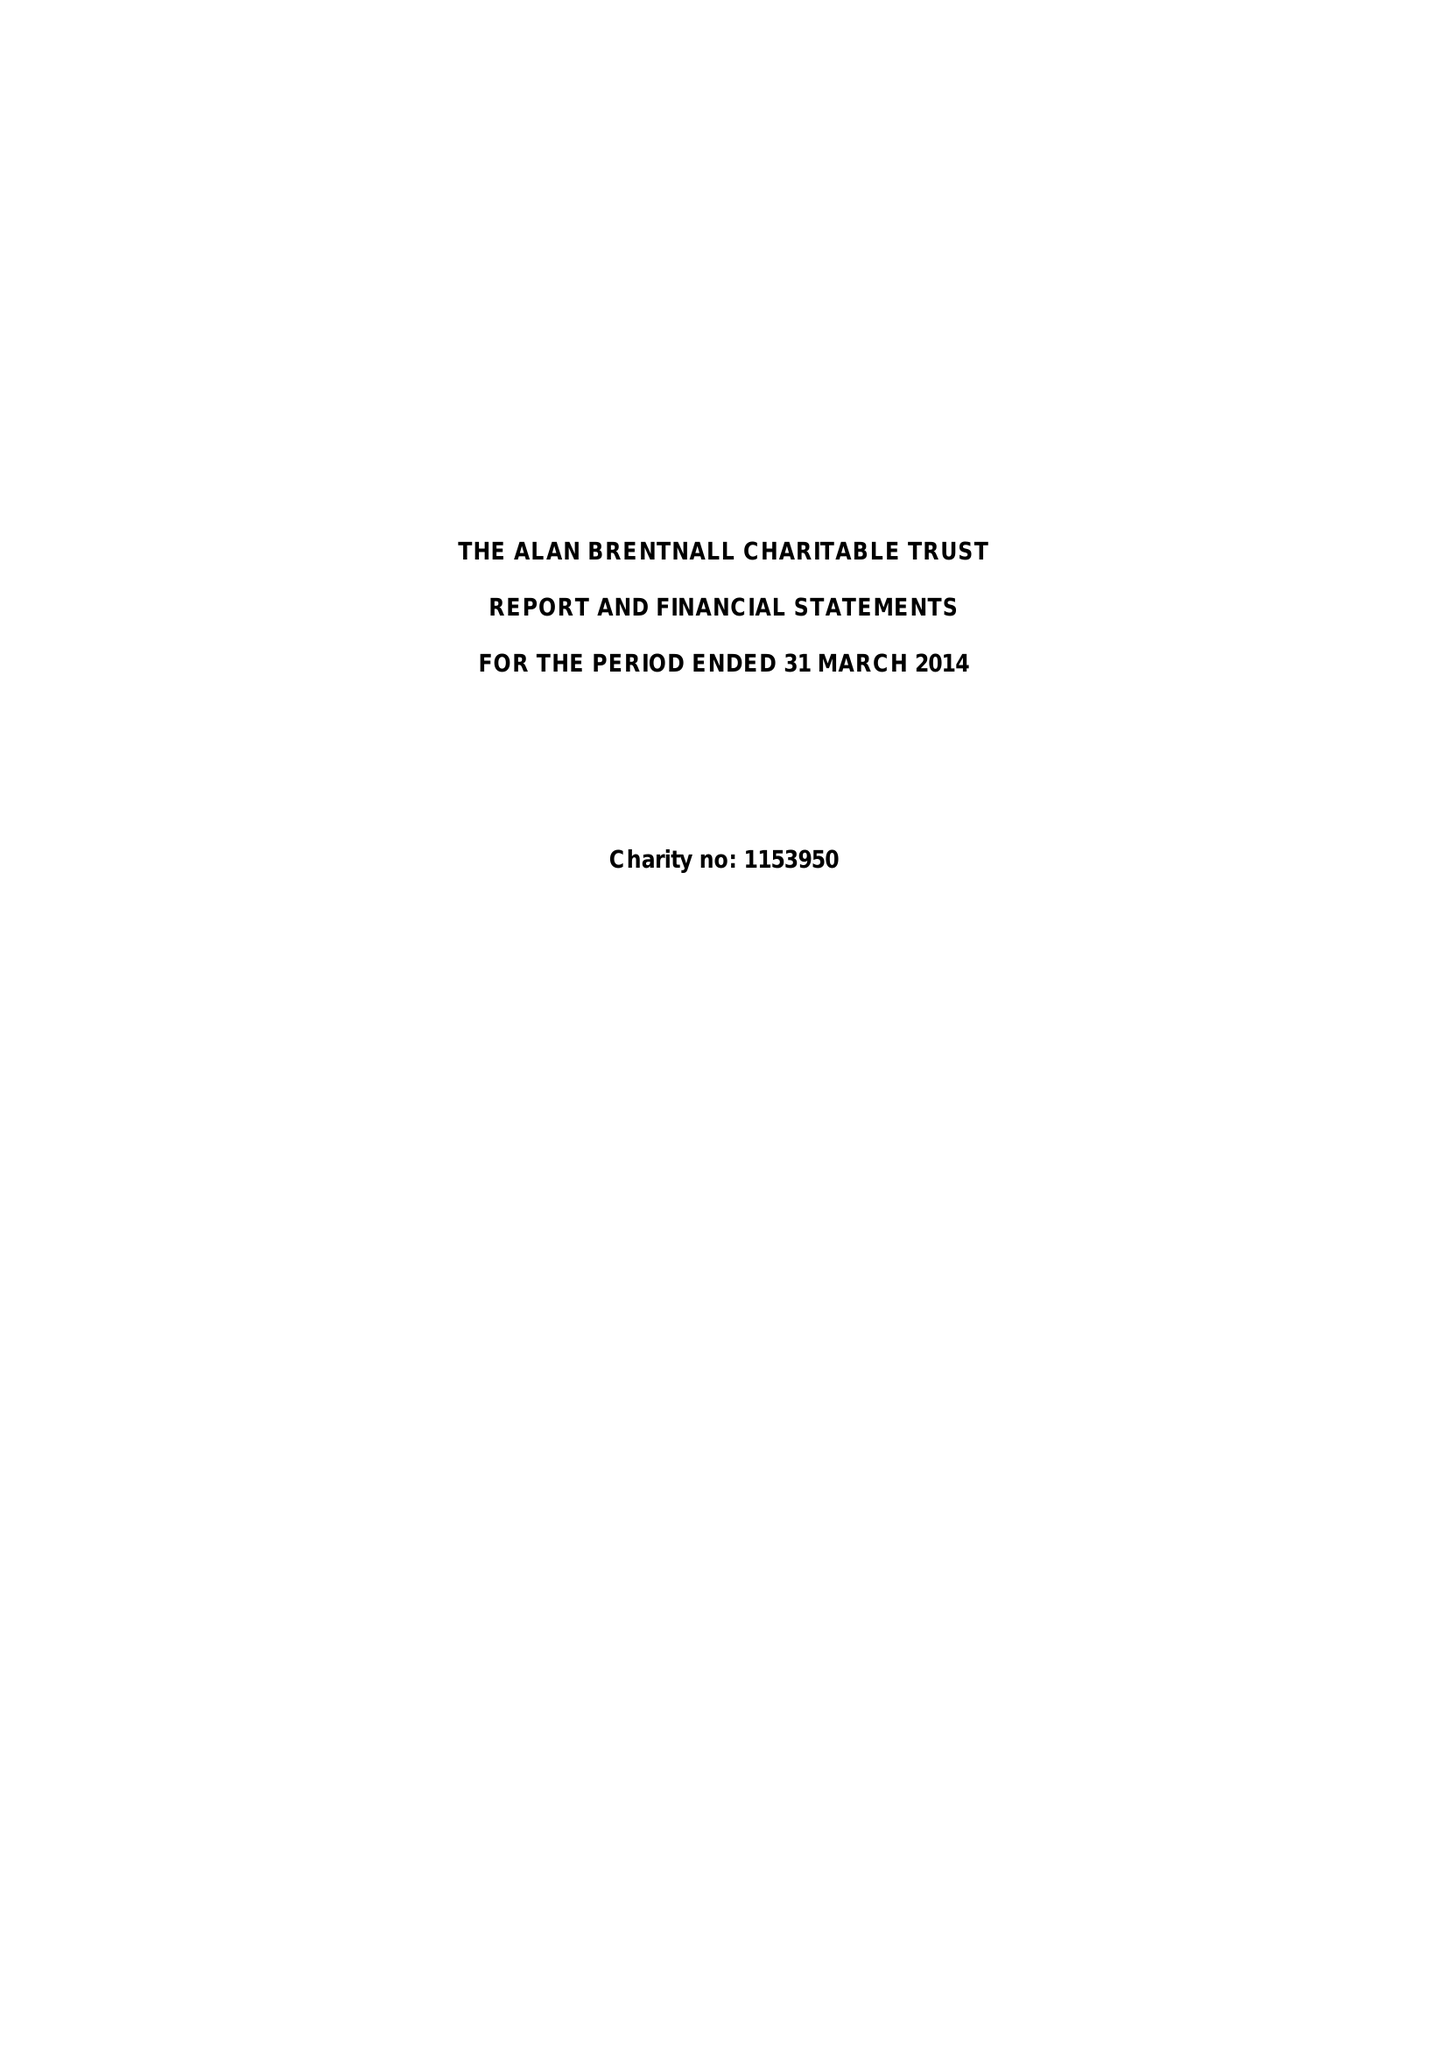What is the value for the address__street_line?
Answer the question using a single word or phrase. NELSON ROAD 